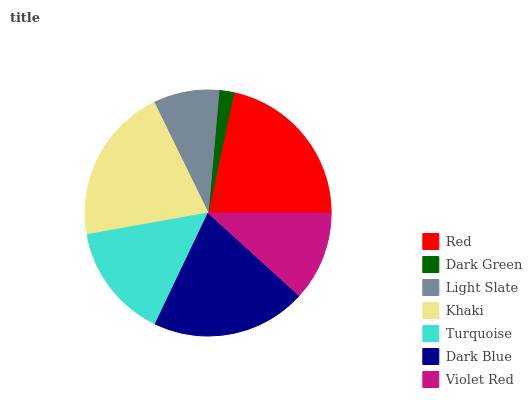Is Dark Green the minimum?
Answer yes or no. Yes. Is Red the maximum?
Answer yes or no. Yes. Is Light Slate the minimum?
Answer yes or no. No. Is Light Slate the maximum?
Answer yes or no. No. Is Light Slate greater than Dark Green?
Answer yes or no. Yes. Is Dark Green less than Light Slate?
Answer yes or no. Yes. Is Dark Green greater than Light Slate?
Answer yes or no. No. Is Light Slate less than Dark Green?
Answer yes or no. No. Is Turquoise the high median?
Answer yes or no. Yes. Is Turquoise the low median?
Answer yes or no. Yes. Is Dark Green the high median?
Answer yes or no. No. Is Violet Red the low median?
Answer yes or no. No. 